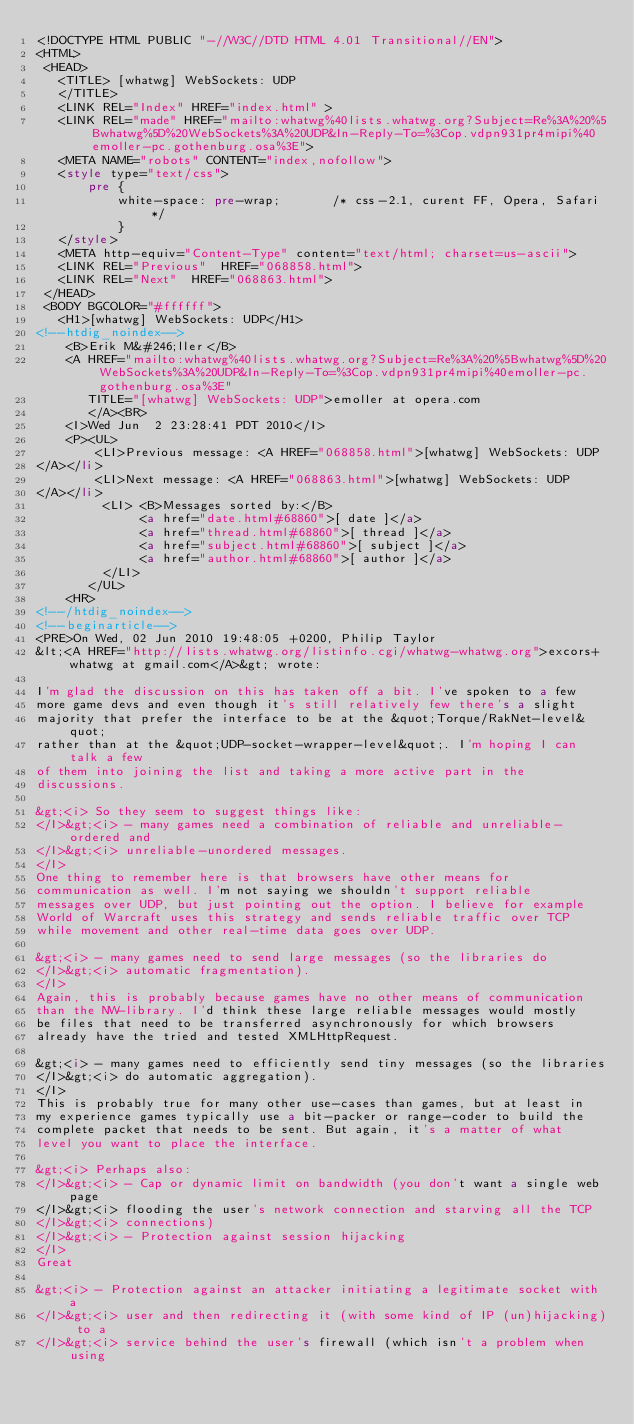<code> <loc_0><loc_0><loc_500><loc_500><_HTML_><!DOCTYPE HTML PUBLIC "-//W3C//DTD HTML 4.01 Transitional//EN">
<HTML>
 <HEAD>
   <TITLE> [whatwg] WebSockets: UDP
   </TITLE>
   <LINK REL="Index" HREF="index.html" >
   <LINK REL="made" HREF="mailto:whatwg%40lists.whatwg.org?Subject=Re%3A%20%5Bwhatwg%5D%20WebSockets%3A%20UDP&In-Reply-To=%3Cop.vdpn931pr4mipi%40emoller-pc.gothenburg.osa%3E">
   <META NAME="robots" CONTENT="index,nofollow">
   <style type="text/css">
       pre {
           white-space: pre-wrap;       /* css-2.1, curent FF, Opera, Safari */
           }
   </style>
   <META http-equiv="Content-Type" content="text/html; charset=us-ascii">
   <LINK REL="Previous"  HREF="068858.html">
   <LINK REL="Next"  HREF="068863.html">
 </HEAD>
 <BODY BGCOLOR="#ffffff">
   <H1>[whatwg] WebSockets: UDP</H1>
<!--htdig_noindex-->
    <B>Erik M&#246;ller</B> 
    <A HREF="mailto:whatwg%40lists.whatwg.org?Subject=Re%3A%20%5Bwhatwg%5D%20WebSockets%3A%20UDP&In-Reply-To=%3Cop.vdpn931pr4mipi%40emoller-pc.gothenburg.osa%3E"
       TITLE="[whatwg] WebSockets: UDP">emoller at opera.com
       </A><BR>
    <I>Wed Jun  2 23:28:41 PDT 2010</I>
    <P><UL>
        <LI>Previous message: <A HREF="068858.html">[whatwg] WebSockets: UDP
</A></li>
        <LI>Next message: <A HREF="068863.html">[whatwg] WebSockets: UDP
</A></li>
         <LI> <B>Messages sorted by:</B> 
              <a href="date.html#68860">[ date ]</a>
              <a href="thread.html#68860">[ thread ]</a>
              <a href="subject.html#68860">[ subject ]</a>
              <a href="author.html#68860">[ author ]</a>
         </LI>
       </UL>
    <HR>  
<!--/htdig_noindex-->
<!--beginarticle-->
<PRE>On Wed, 02 Jun 2010 19:48:05 +0200, Philip Taylor  
&lt;<A HREF="http://lists.whatwg.org/listinfo.cgi/whatwg-whatwg.org">excors+whatwg at gmail.com</A>&gt; wrote:

I'm glad the discussion on this has taken off a bit. I've spoken to a few  
more game devs and even though it's still relatively few there's a slight  
majority that prefer the interface to be at the &quot;Torque/RakNet-level&quot;  
rather than at the &quot;UDP-socket-wrapper-level&quot;. I'm hoping I can talk a few  
of them into joining the list and taking a more active part in the  
discussions.

&gt;<i> So they seem to suggest things like:
</I>&gt;<i> - many games need a combination of reliable and unreliable-ordered and
</I>&gt;<i> unreliable-unordered messages.
</I>
One thing to remember here is that browsers have other means for  
communication as well. I'm not saying we shouldn't support reliable  
messages over UDP, but just pointing out the option. I believe for example  
World of Warcraft uses this strategy and sends reliable traffic over TCP  
while movement and other real-time data goes over UDP.

&gt;<i> - many games need to send large messages (so the libraries do
</I>&gt;<i> automatic fragmentation).
</I>
Again, this is probably because games have no other means of communication  
than the NW-library. I'd think these large reliable messages would mostly  
be files that need to be transferred asynchronously for which browsers  
already have the tried and tested XMLHttpRequest.

&gt;<i> - many games need to efficiently send tiny messages (so the libraries
</I>&gt;<i> do automatic aggregation).
</I>
This is probably true for many other use-cases than games, but at least in  
my experience games typically use a bit-packer or range-coder to build the  
complete packet that needs to be sent. But again, it's a matter of what  
level you want to place the interface.

&gt;<i> Perhaps also:
</I>&gt;<i> - Cap or dynamic limit on bandwidth (you don't want a single web page
</I>&gt;<i> flooding the user's network connection and starving all the TCP
</I>&gt;<i> connections)
</I>&gt;<i> - Protection against session hijacking
</I>
Great

&gt;<i> - Protection against an attacker initiating a legitimate socket with a
</I>&gt;<i> user and then redirecting it (with some kind of IP (un)hijacking) to a
</I>&gt;<i> service behind the user's firewall (which isn't a problem when using</code> 